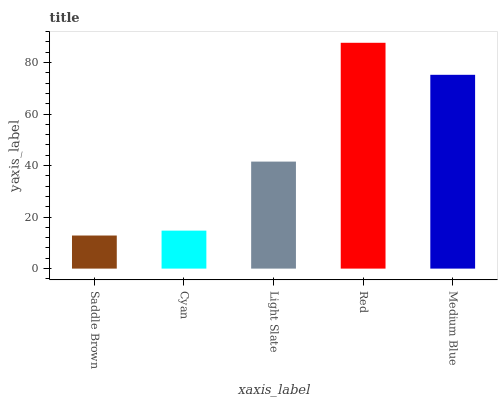Is Saddle Brown the minimum?
Answer yes or no. Yes. Is Red the maximum?
Answer yes or no. Yes. Is Cyan the minimum?
Answer yes or no. No. Is Cyan the maximum?
Answer yes or no. No. Is Cyan greater than Saddle Brown?
Answer yes or no. Yes. Is Saddle Brown less than Cyan?
Answer yes or no. Yes. Is Saddle Brown greater than Cyan?
Answer yes or no. No. Is Cyan less than Saddle Brown?
Answer yes or no. No. Is Light Slate the high median?
Answer yes or no. Yes. Is Light Slate the low median?
Answer yes or no. Yes. Is Cyan the high median?
Answer yes or no. No. Is Medium Blue the low median?
Answer yes or no. No. 